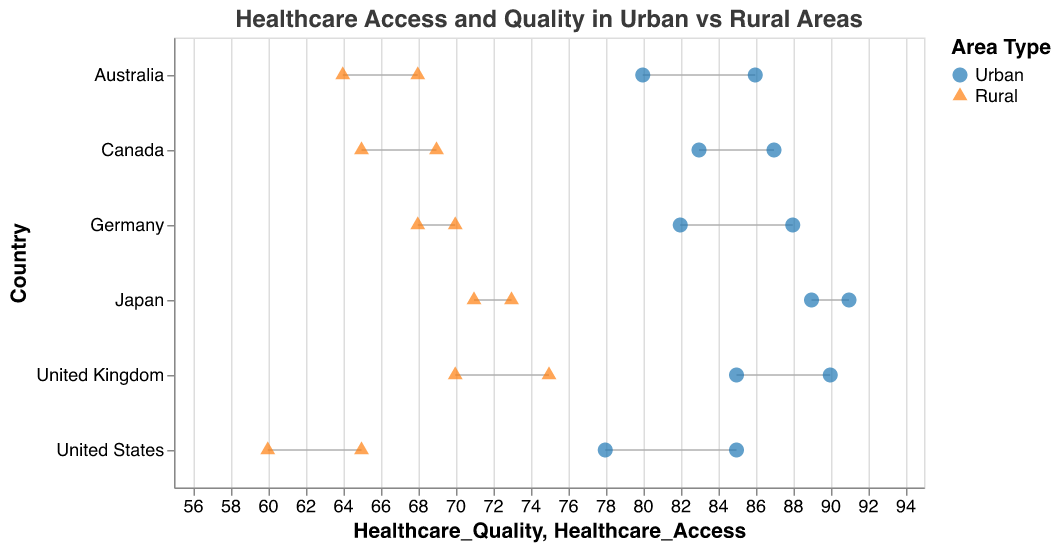What's the title of the figure? The title of the figure is prominently displayed at the top of the chart.
Answer: Healthcare Access and Quality in Urban vs Rural Areas Which area type has the highest healthcare quality score in the United States? The color and shape of the dot indicate the area type, and the dot's position along the x-axis represents the healthcare quality score. The dark blue circle (Urban) has the highest score at 78.
Answer: Urban What is the difference in healthcare access between urban and rural areas in Germany? Find the healthcare access scores for both urban (88) and rural (70) areas and subtract the rural score from the urban score: 88 - 70.
Answer: 18 How does healthcare access in rural Japan compare to urban Australia? Compare the healthcare access scores: rural Japan (73) and urban Australia (86).
Answer: Rural Japan (73) is lower than urban Australia (86) What is the average healthcare access score for urban areas across all countries? Sum the healthcare access scores for urban areas and divide by the number of countries:
(85 + 90 + 88 + 87 + 86 + 91) / 6 = 527 / 6.
Answer: 87.83 Which country has the highest overall healthcare quality score in rural areas? Identify the highest healthcare quality score in rural areas: United States (60), UK (70), Germany (68), Canada (65), Australia (64), Japan (71).
Answer: UK (70) What is the median healthcare quality score for urban areas? List the healthcare quality scores for urban areas: 78, 85, 82, 83, 80, 89. Arrange in ascending order: 78, 80, 82, 83, 85, 89. The median is the average of the two middle values (82 and 83). (82 + 83) / 2.
Answer: 82.5 